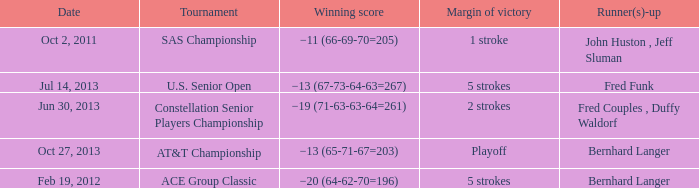Which Tournament has a Date of jul 14, 2013? U.S. Senior Open. 